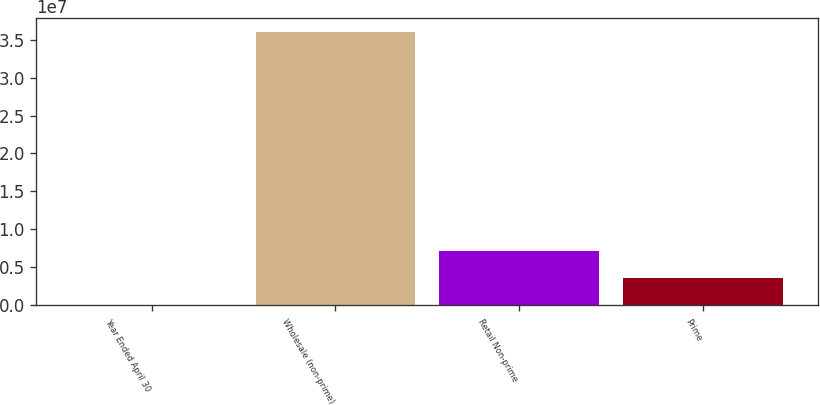<chart> <loc_0><loc_0><loc_500><loc_500><bar_chart><fcel>Year Ended April 30<fcel>Wholesale (non-prime)<fcel>Retail Non-prime<fcel>Prime<nl><fcel>2006<fcel>3.60288e+07<fcel>7.20736e+06<fcel>3.60468e+06<nl></chart> 